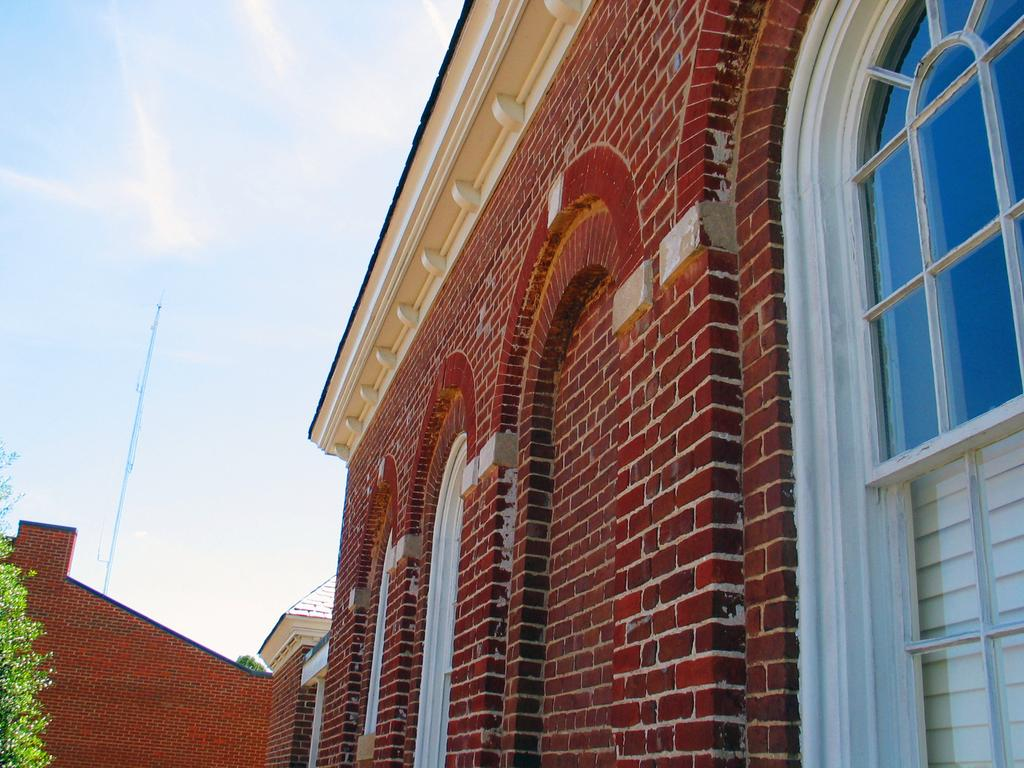What type of structures can be seen in the image? There are buildings in the image. What part of the buildings can be seen in the image? There is a window in the image. What type of vegetation is present in the image? There is a tree in the image. What is visible in the background of the image? The sky is visible in the image. What type of cord is hanging from the tree in the image? There is no cord hanging from the tree in the image. 